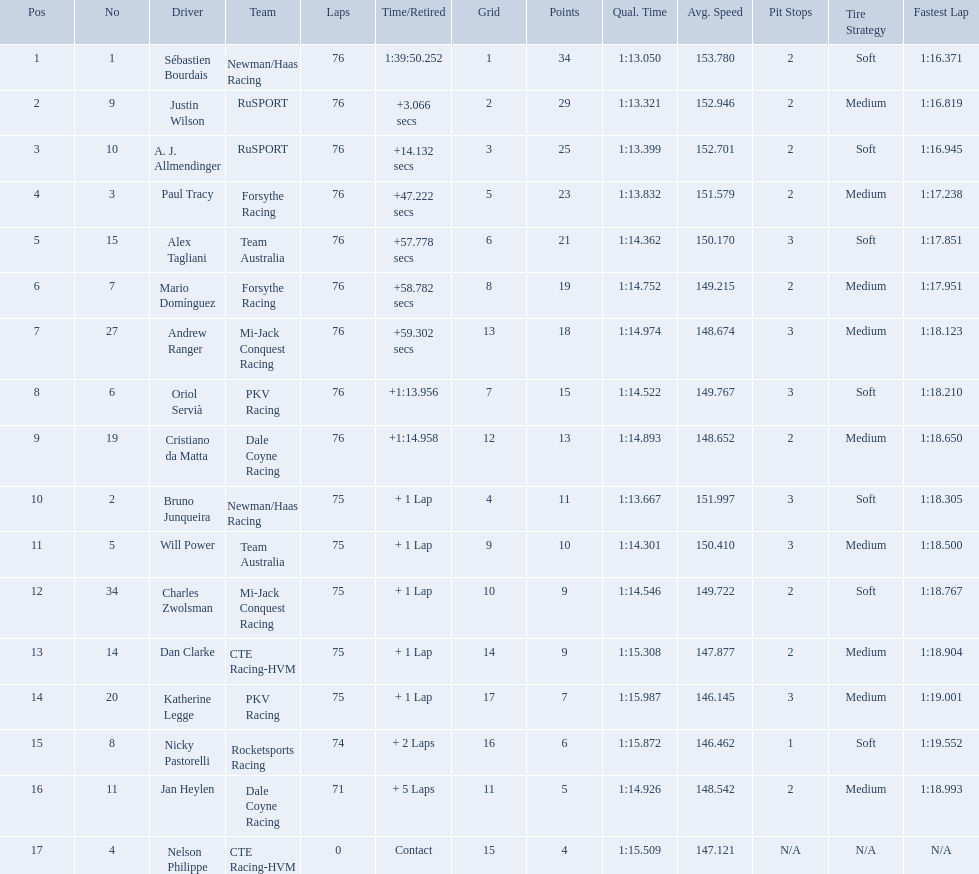What was alex taglini's final score in the tecate grand prix? 21. What was paul tracy's final score in the tecate grand prix? 23. Which driver finished first? Paul Tracy. 